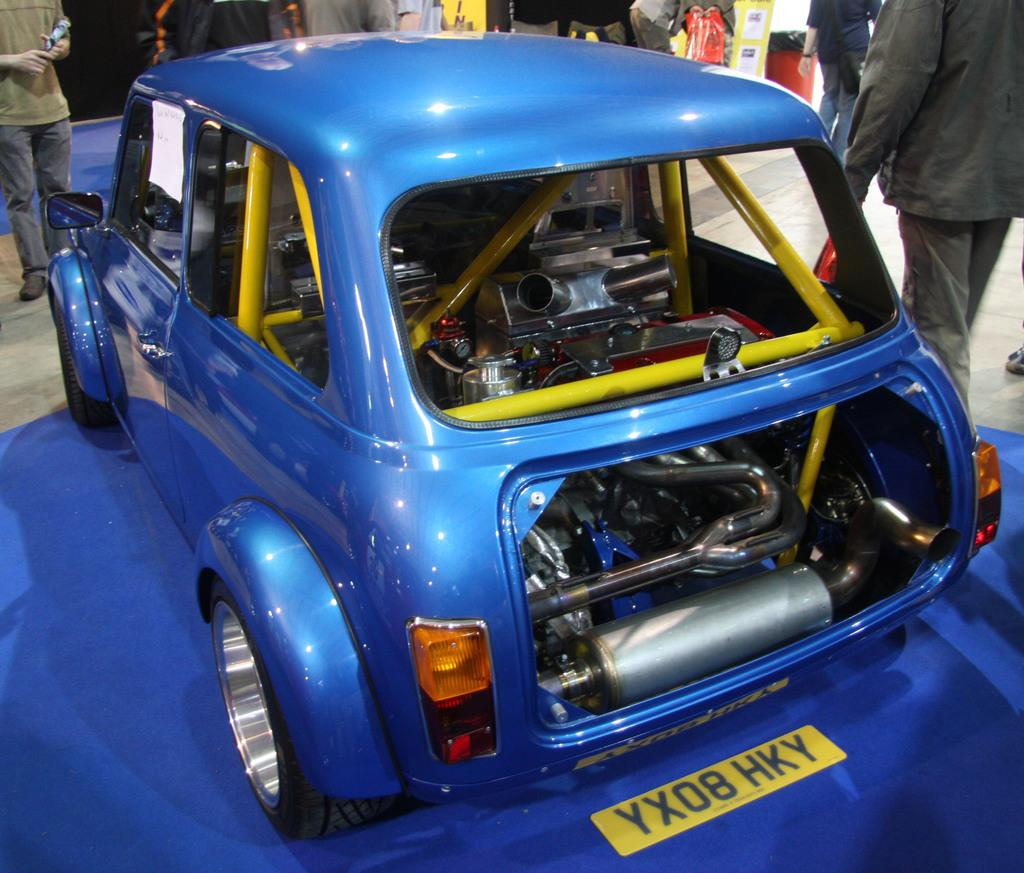What is the main subject of the image? There is a vehicle in the image. Can you describe the color of the vehicle? The vehicle is blue. What else can be seen in the background of the image? There are people standing in the background of the image. Is there any other object in the image with a distinct color? Yes, there is an object in red color in the image. What type of cake is being prepared by the actor in the image? There is no actor or cake present in the image; it features a blue vehicle and people standing in the background. 